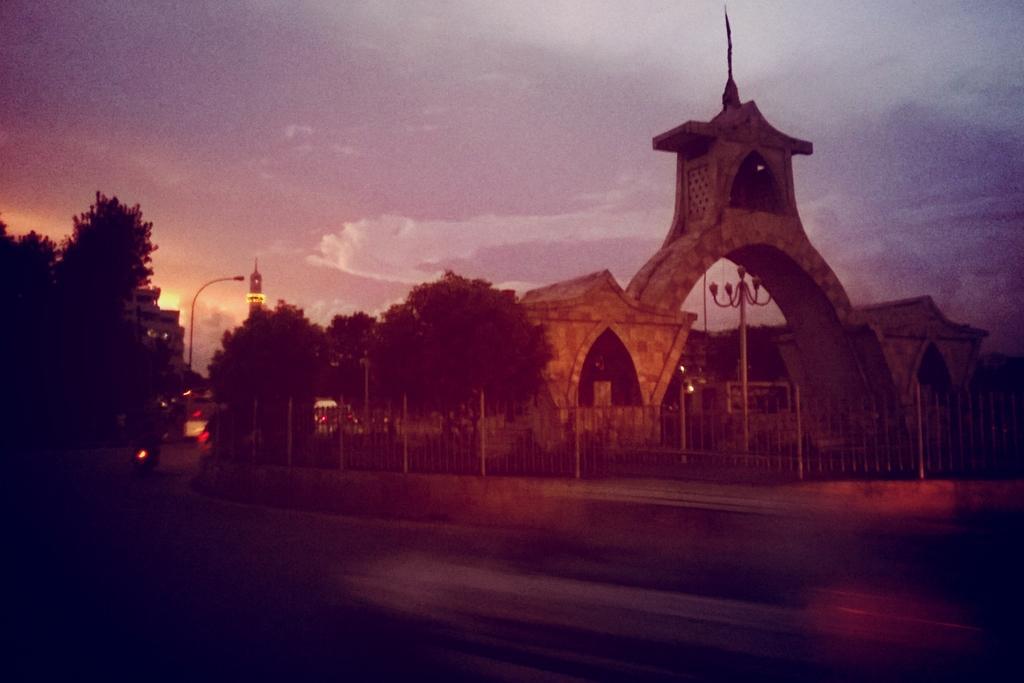Please provide a concise description of this image. This is an image clicked in the dark. At the bottom there is a road. On the right side there is a building and a fencing. On the left side there are many trees and few vehicles on the road. Beside the road there are few light poles. At the top of the image I can see the sky. 